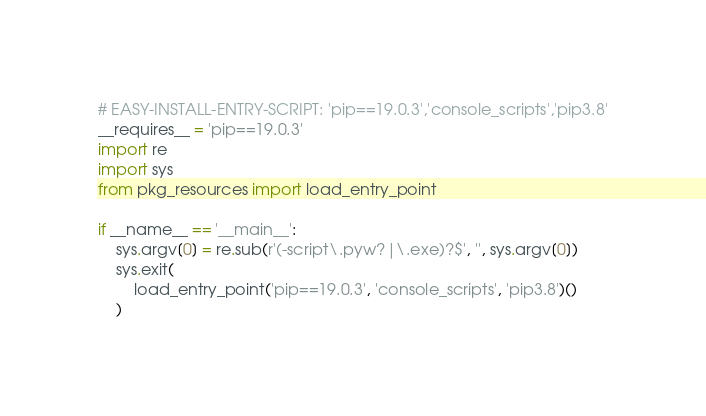Convert code to text. <code><loc_0><loc_0><loc_500><loc_500><_Python_># EASY-INSTALL-ENTRY-SCRIPT: 'pip==19.0.3','console_scripts','pip3.8'
__requires__ = 'pip==19.0.3'
import re
import sys
from pkg_resources import load_entry_point

if __name__ == '__main__':
    sys.argv[0] = re.sub(r'(-script\.pyw?|\.exe)?$', '', sys.argv[0])
    sys.exit(
        load_entry_point('pip==19.0.3', 'console_scripts', 'pip3.8')()
    )
</code> 